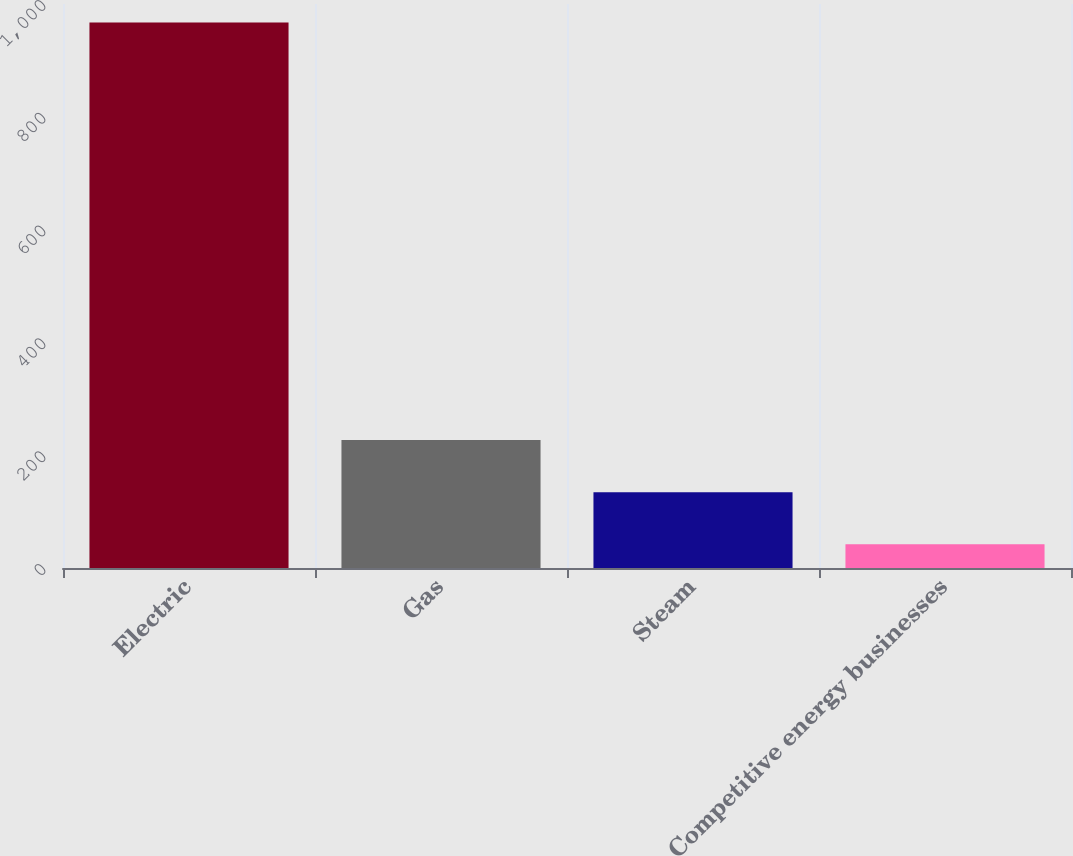<chart> <loc_0><loc_0><loc_500><loc_500><bar_chart><fcel>Electric<fcel>Gas<fcel>Steam<fcel>Competitive energy businesses<nl><fcel>967<fcel>227<fcel>134.5<fcel>42<nl></chart> 